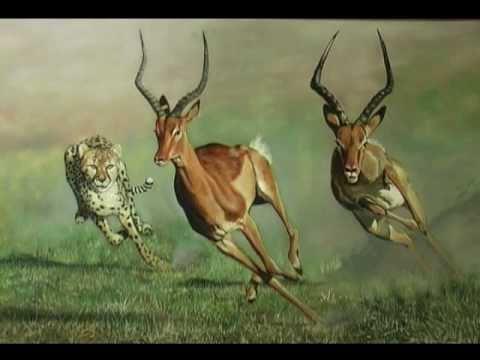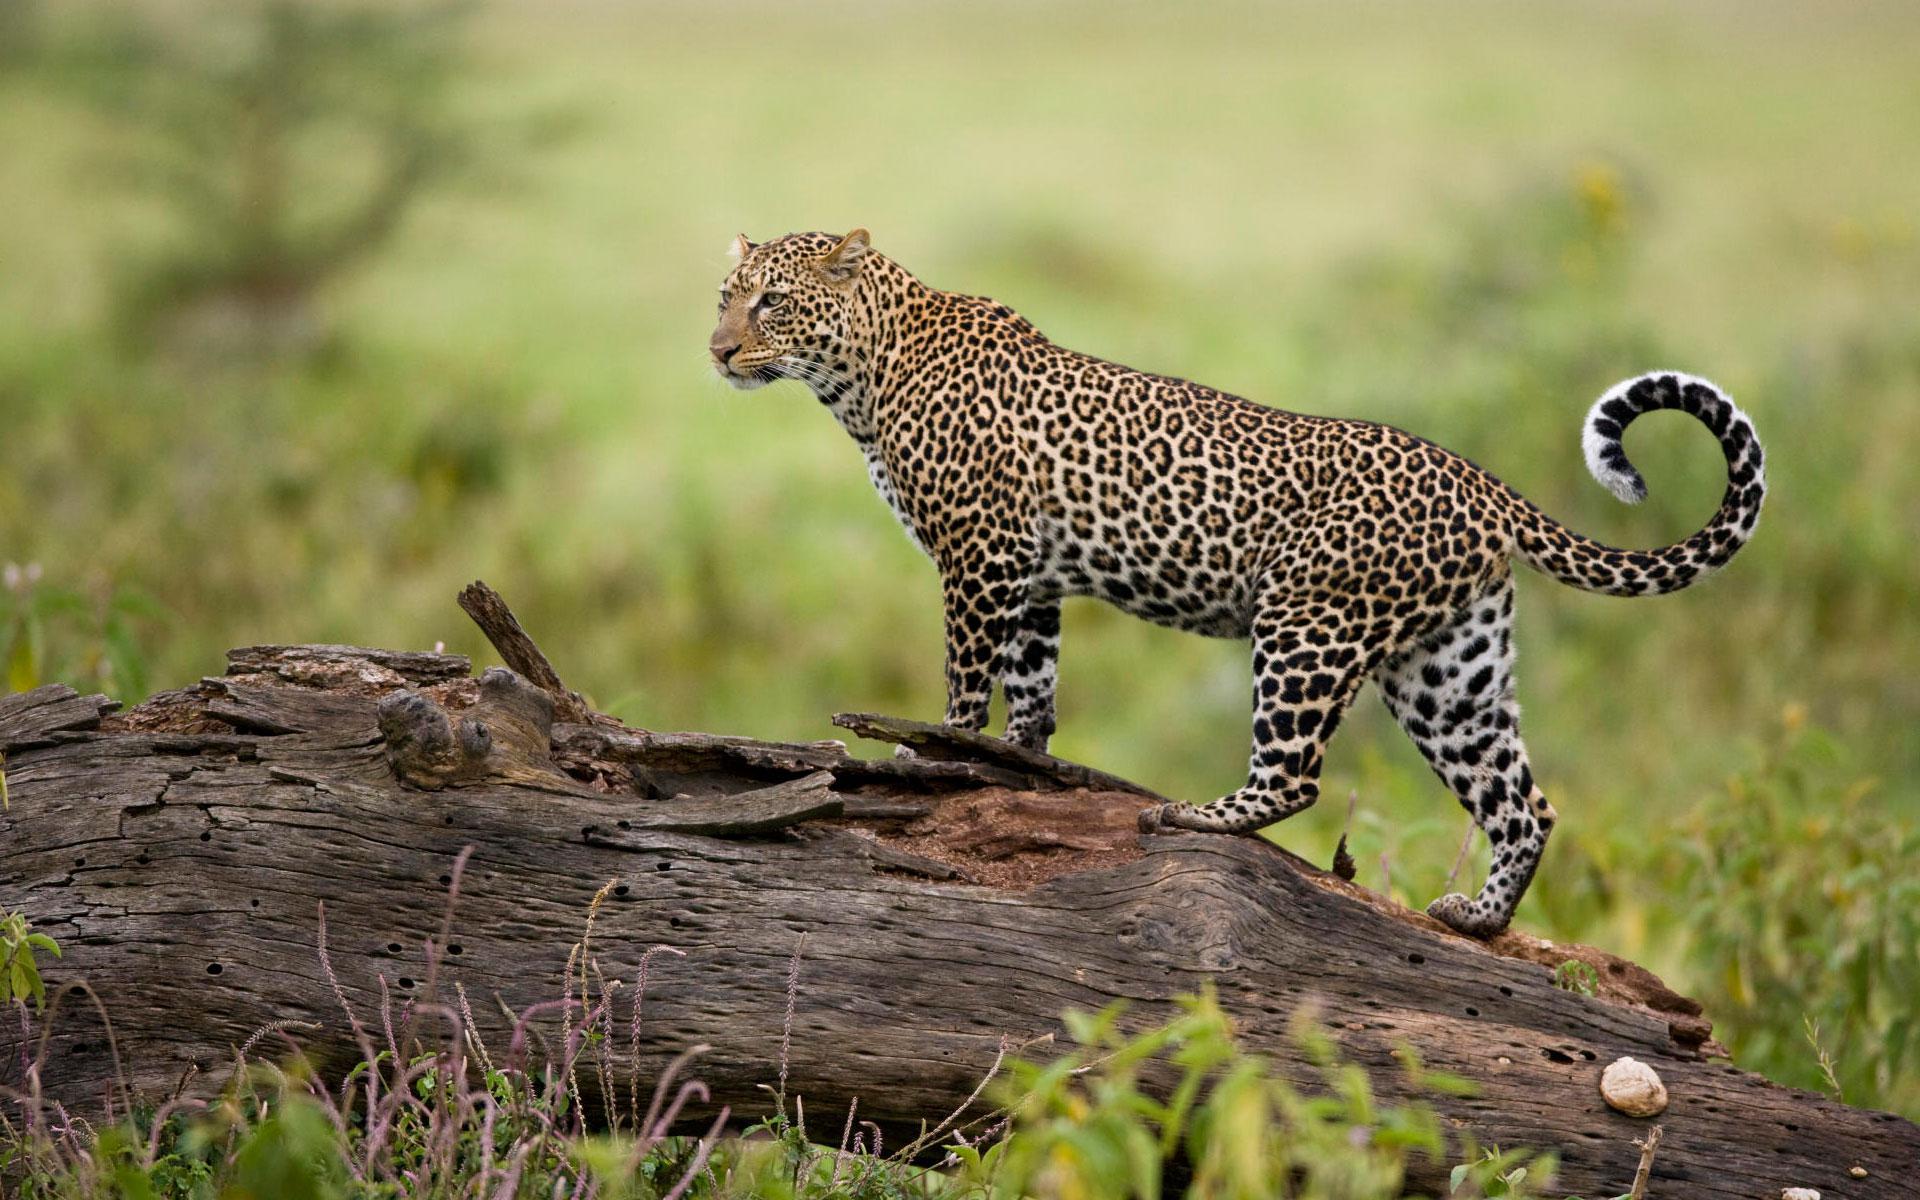The first image is the image on the left, the second image is the image on the right. Analyze the images presented: Is the assertion "One leopard is chasing a young deer while another leopard will have antelope for the meal." valid? Answer yes or no. No. 